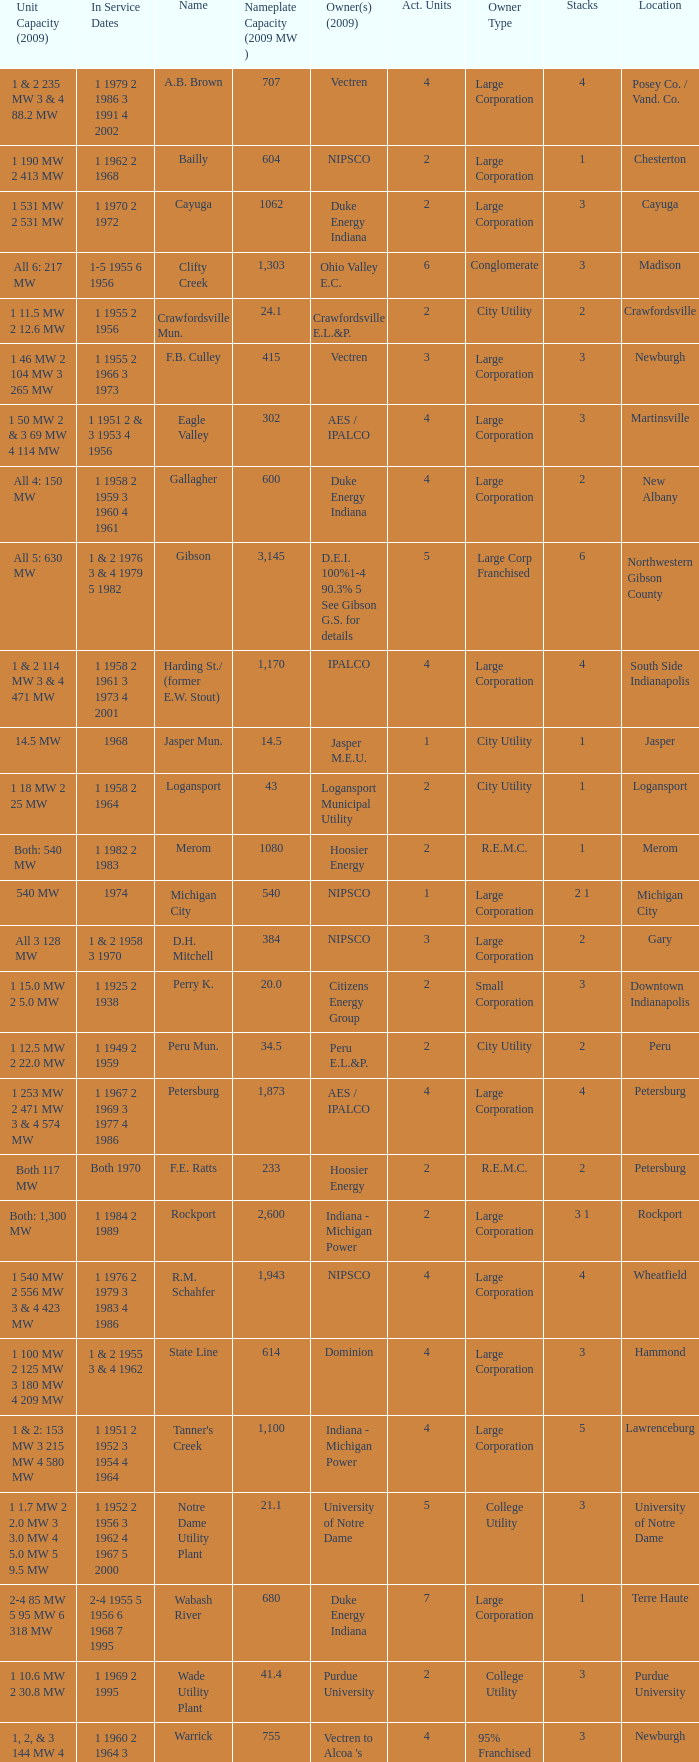Name the owners 2009 for south side indianapolis IPALCO. 